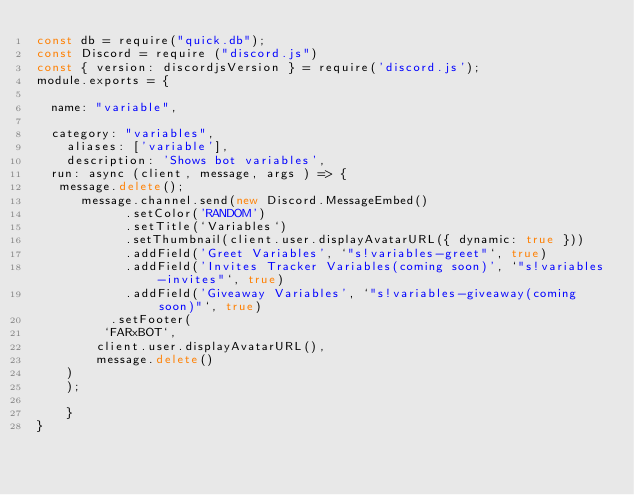<code> <loc_0><loc_0><loc_500><loc_500><_JavaScript_>const db = require("quick.db");
const Discord = require ("discord.js")
const { version: discordjsVersion } = require('discord.js');
module.exports = {

  name: "variable",

  category: "variables",
    aliases: ['variable'],
    description: 'Shows bot variables',
  run: async (client, message, args ) => {
   message.delete();
      message.channel.send(new Discord.MessageEmbed()
            .setColor('RANDOM')
            .setTitle(`Variables`)
            .setThumbnail(client.user.displayAvatarURL({ dynamic: true }))
            .addField('Greet Variables', `"s!variables-greet"`, true)
            .addField('Invites Tracker Variables(coming soon)', `"s!variables-invites"`, true)
            .addField('Giveaway Variables', `"s!variables-giveaway(coming soon)"`, true)
          .setFooter(
         `FARxBOT`,
        client.user.displayAvatarURL(),
        message.delete()
    )
    );
  
    }
}
</code> 